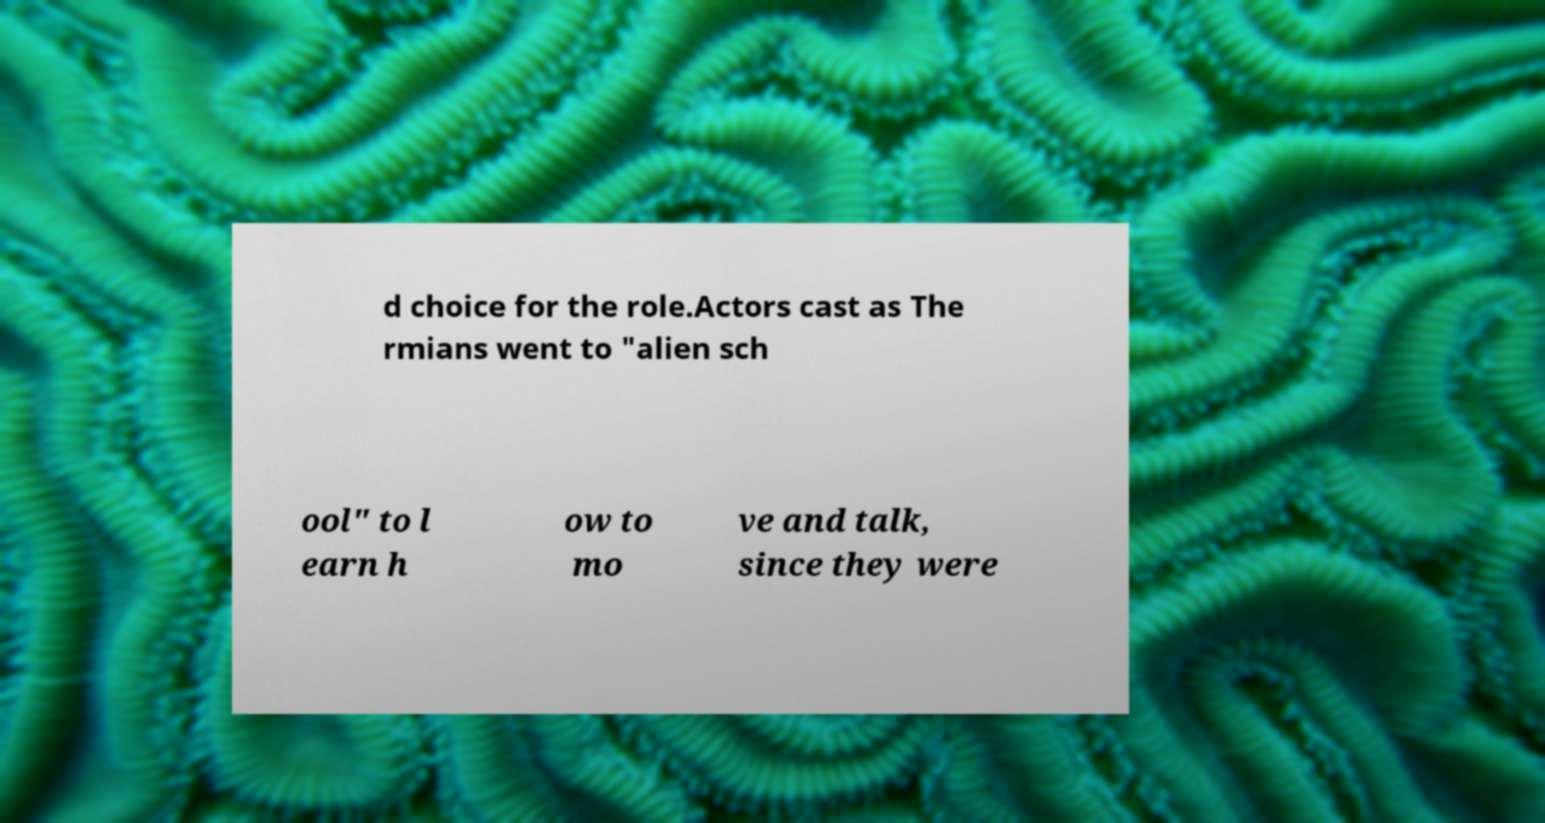Please read and relay the text visible in this image. What does it say? d choice for the role.Actors cast as The rmians went to "alien sch ool" to l earn h ow to mo ve and talk, since they were 